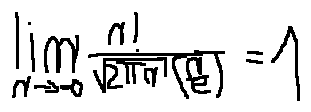Convert formula to latex. <formula><loc_0><loc_0><loc_500><loc_500>\lim \lim i t s _ { n \rightarrow \infty } \frac { n ! } { \sqrt { 2 \pi n } ( \frac { n } { e } ) } = 1</formula> 